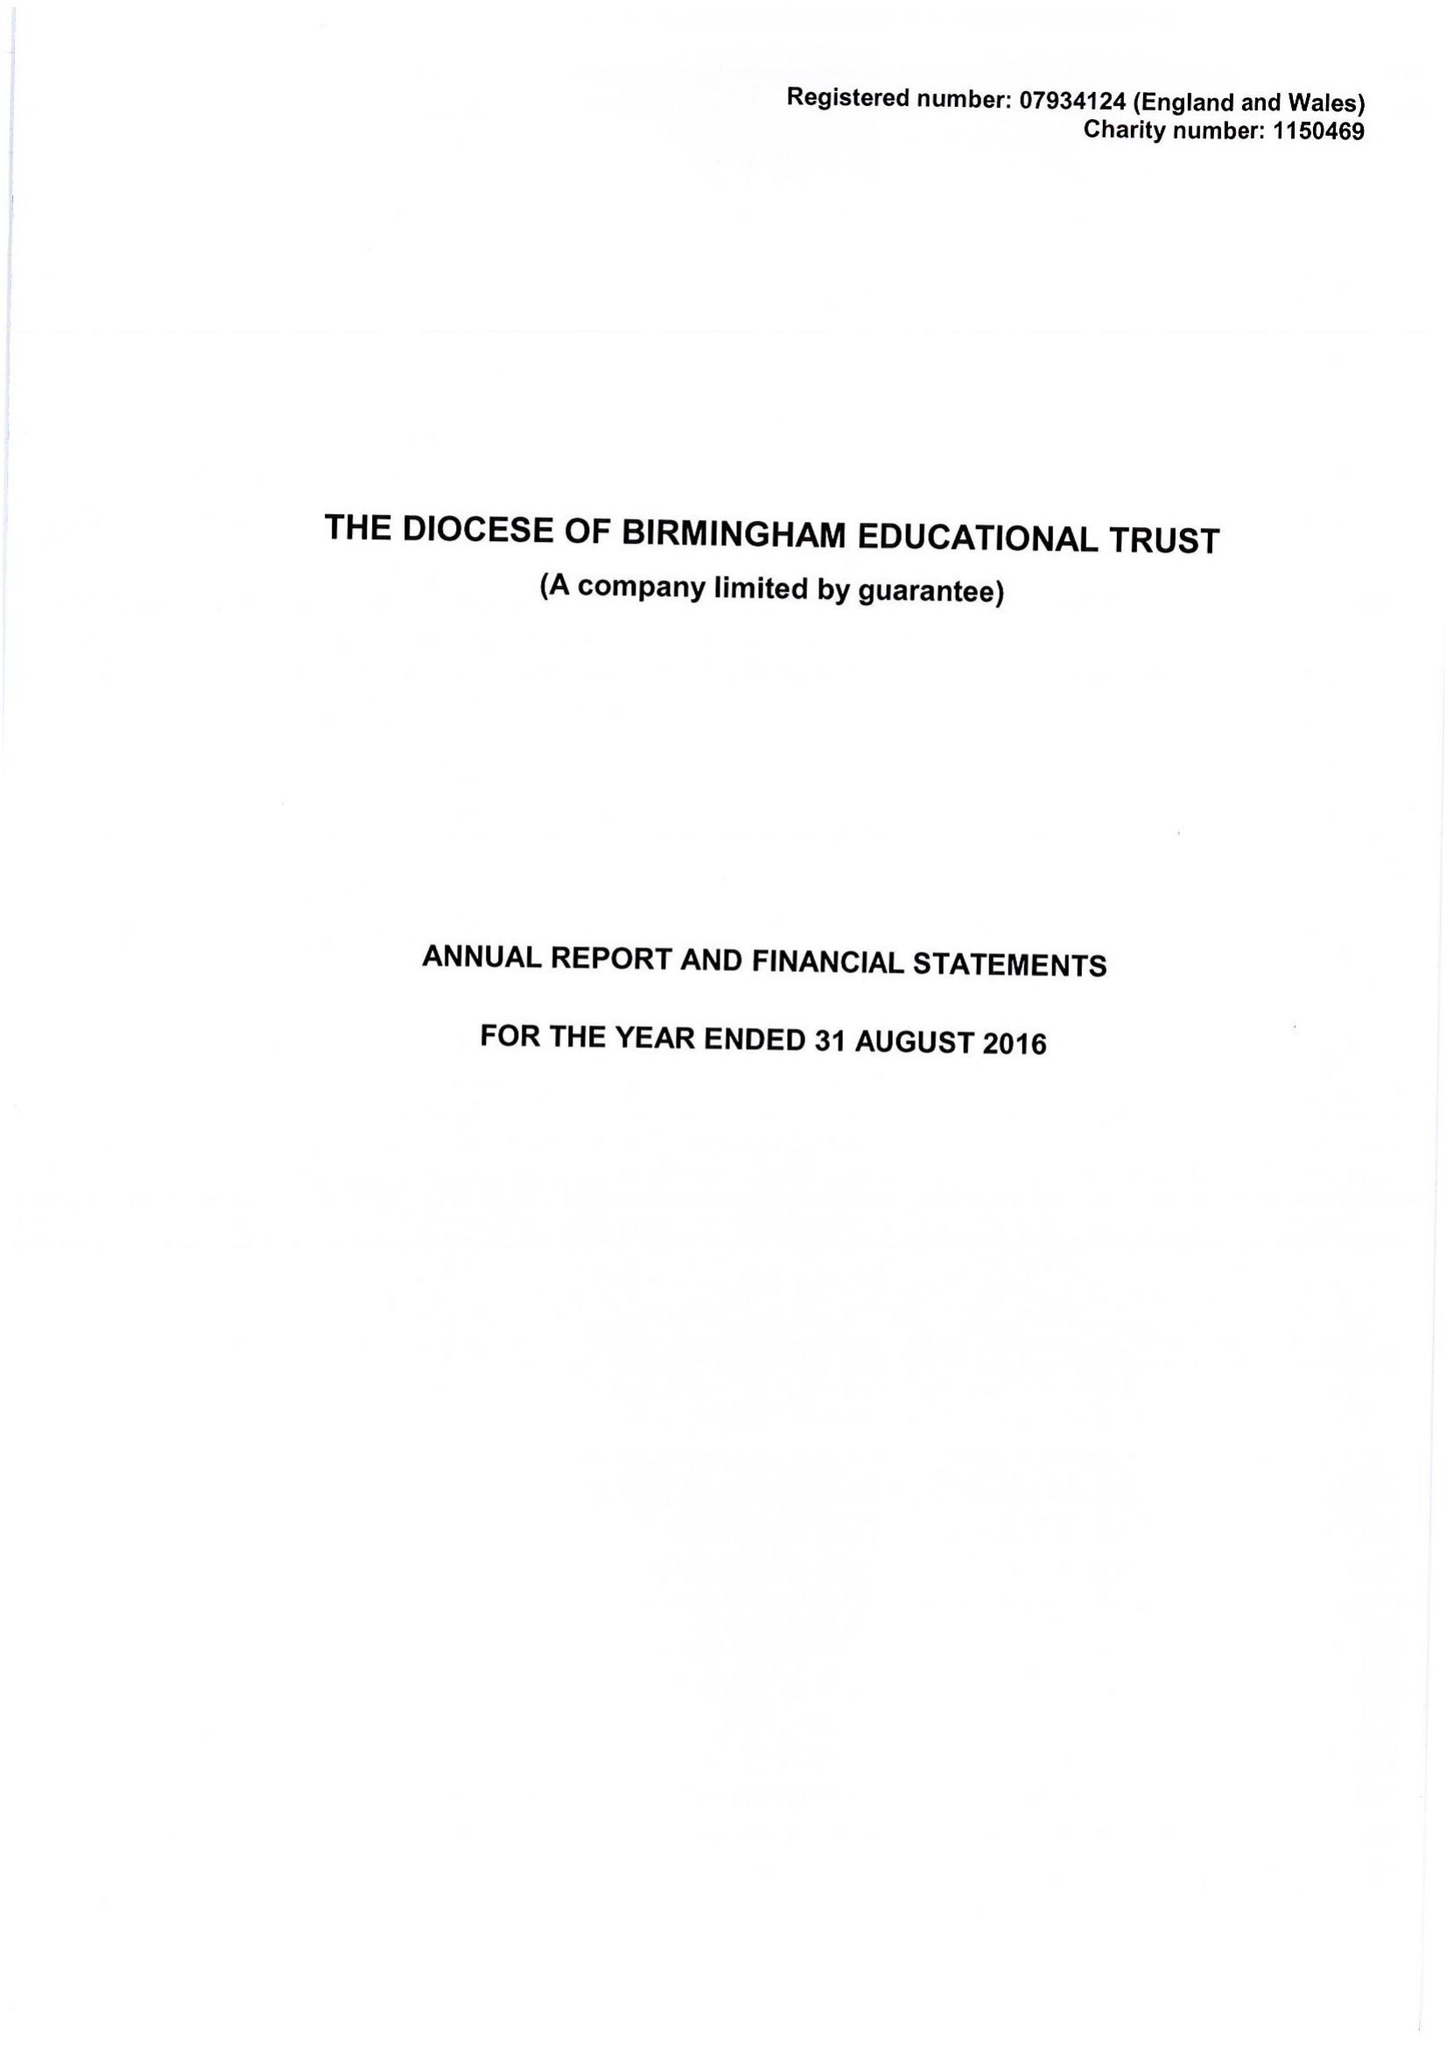What is the value for the address__postcode?
Answer the question using a single word or phrase. B3 2BJ 